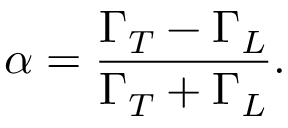Convert formula to latex. <formula><loc_0><loc_0><loc_500><loc_500>\alpha = \frac { \Gamma _ { T } - \Gamma _ { L } } { \Gamma _ { T } + \Gamma _ { L } } .</formula> 